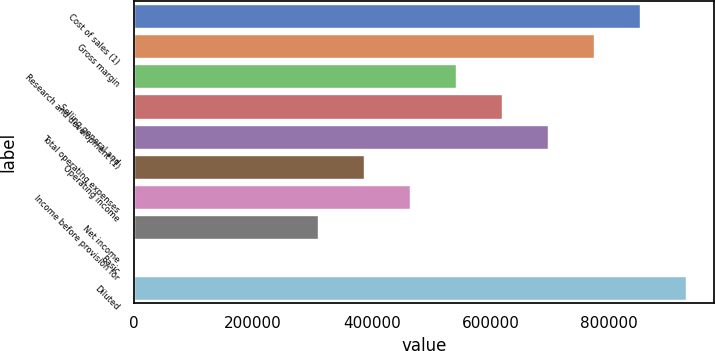Convert chart. <chart><loc_0><loc_0><loc_500><loc_500><bar_chart><fcel>Cost of sales (1)<fcel>Gross margin<fcel>Research and development (1)<fcel>Selling general and<fcel>Total operating expenses<fcel>Operating income<fcel>Income before provision for<fcel>Net income<fcel>Basic<fcel>Diluted<nl><fcel>852254<fcel>774776<fcel>542343<fcel>619821<fcel>697298<fcel>387388<fcel>464866<fcel>309911<fcel>0.36<fcel>929731<nl></chart> 